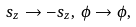Convert formula to latex. <formula><loc_0><loc_0><loc_500><loc_500>s _ { z } \to - s _ { z } , \, \phi \to \phi , \,</formula> 